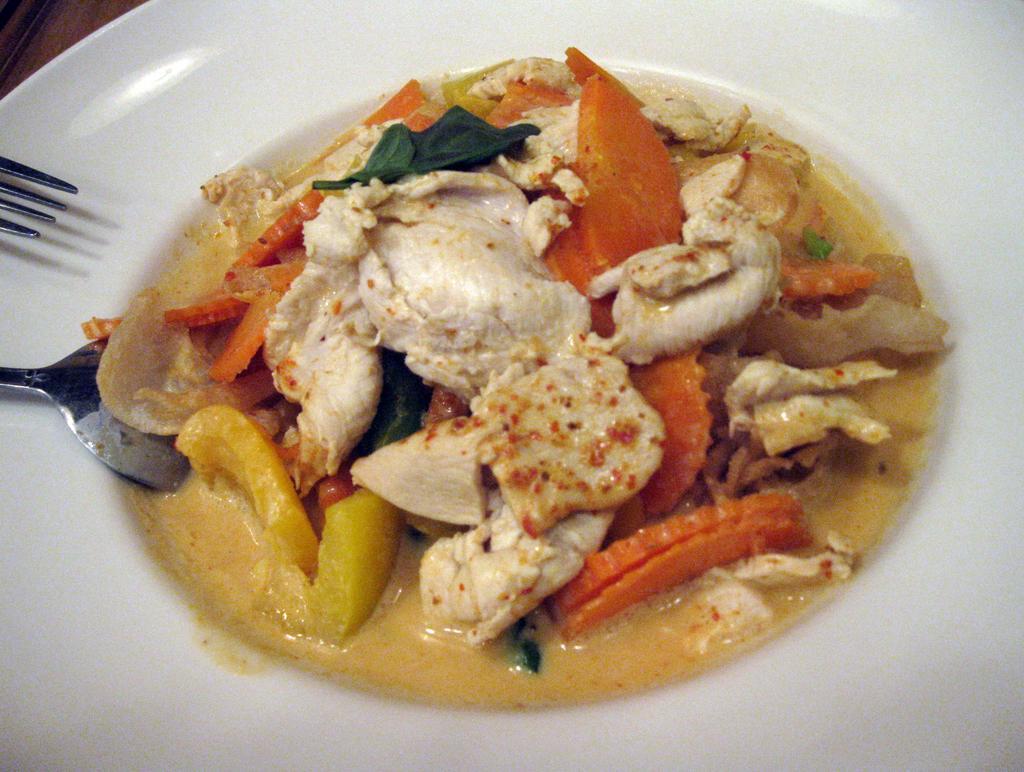In one or two sentences, can you explain what this image depicts? In this picture we can observe some food places in the white color plate. This food is in orange, white and yellow colors. We can observe a spoon and a fork on the left side. 